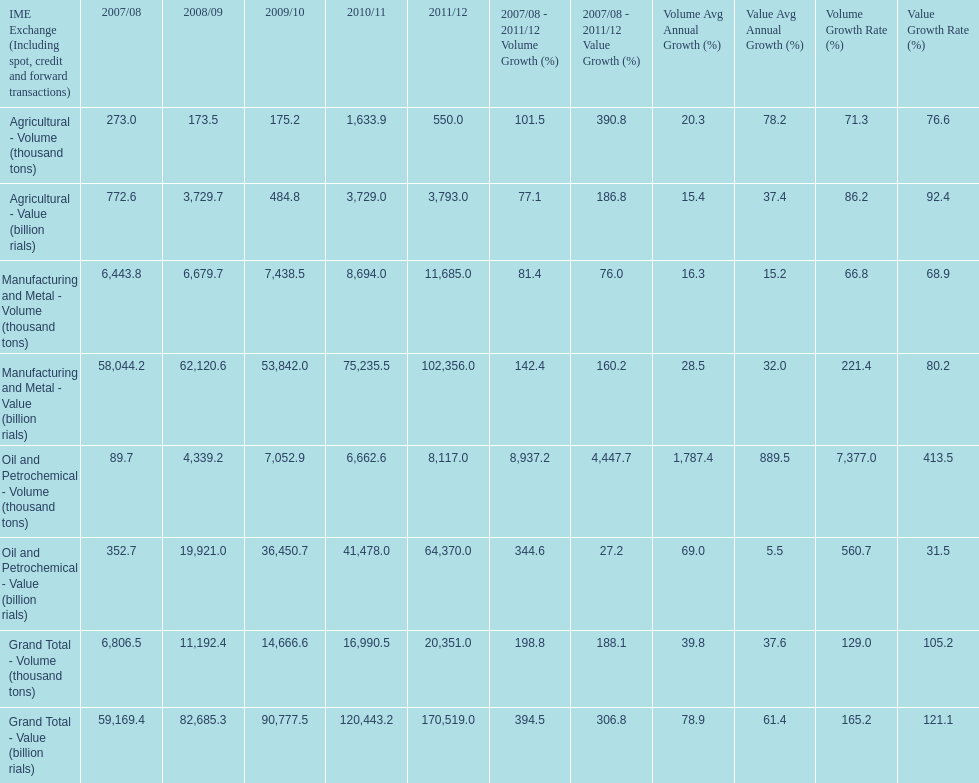How many consecutive year did the grand total value grow in iran? 4. 